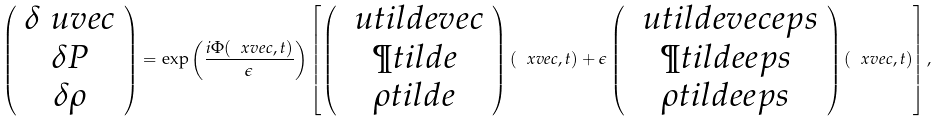<formula> <loc_0><loc_0><loc_500><loc_500>\left ( \begin{array} { c } \delta \ u v e c \\ \delta P \\ \delta \rho \end{array} \right ) = \exp \left ( \frac { i \Phi ( \ x v e c , t ) } { \epsilon } \right ) \left [ \left ( \begin{array} { c } \ u t i l d e v e c \\ \P t i l d e \\ \rho t i l d e \end{array} \right ) ( \ x v e c , t ) + \epsilon \left ( \begin{array} { c } \ u t i l d e v e c e p s \\ \P t i l d e e p s \\ \rho t i l d e e p s \end{array} \right ) ( \ x v e c , t ) \right ] ,</formula> 